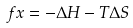Convert formula to latex. <formula><loc_0><loc_0><loc_500><loc_500>f x = - \Delta H - T \Delta S</formula> 